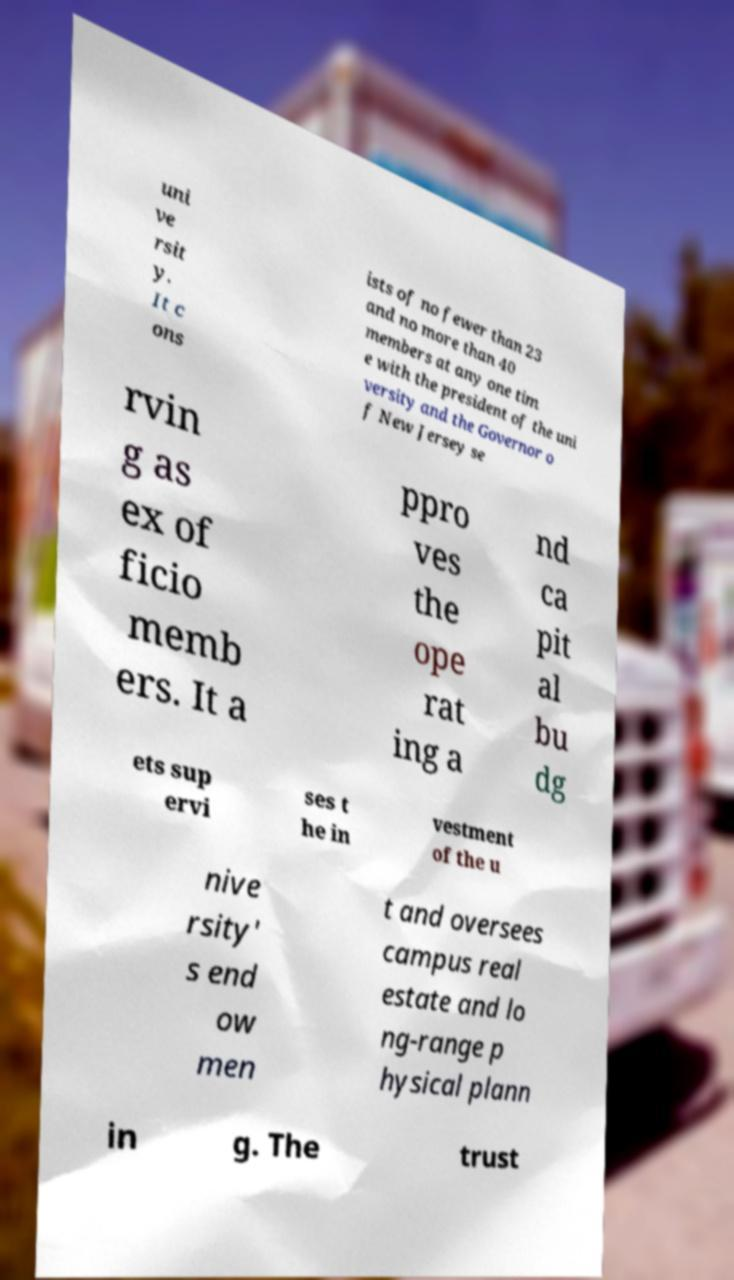Could you extract and type out the text from this image? uni ve rsit y. It c ons ists of no fewer than 23 and no more than 40 members at any one tim e with the president of the uni versity and the Governor o f New Jersey se rvin g as ex of ficio memb ers. It a ppro ves the ope rat ing a nd ca pit al bu dg ets sup ervi ses t he in vestment of the u nive rsity' s end ow men t and oversees campus real estate and lo ng-range p hysical plann in g. The trust 